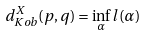<formula> <loc_0><loc_0><loc_500><loc_500>d ^ { X } _ { K o b } ( p , q ) = \inf _ { \alpha } l ( \alpha )</formula> 